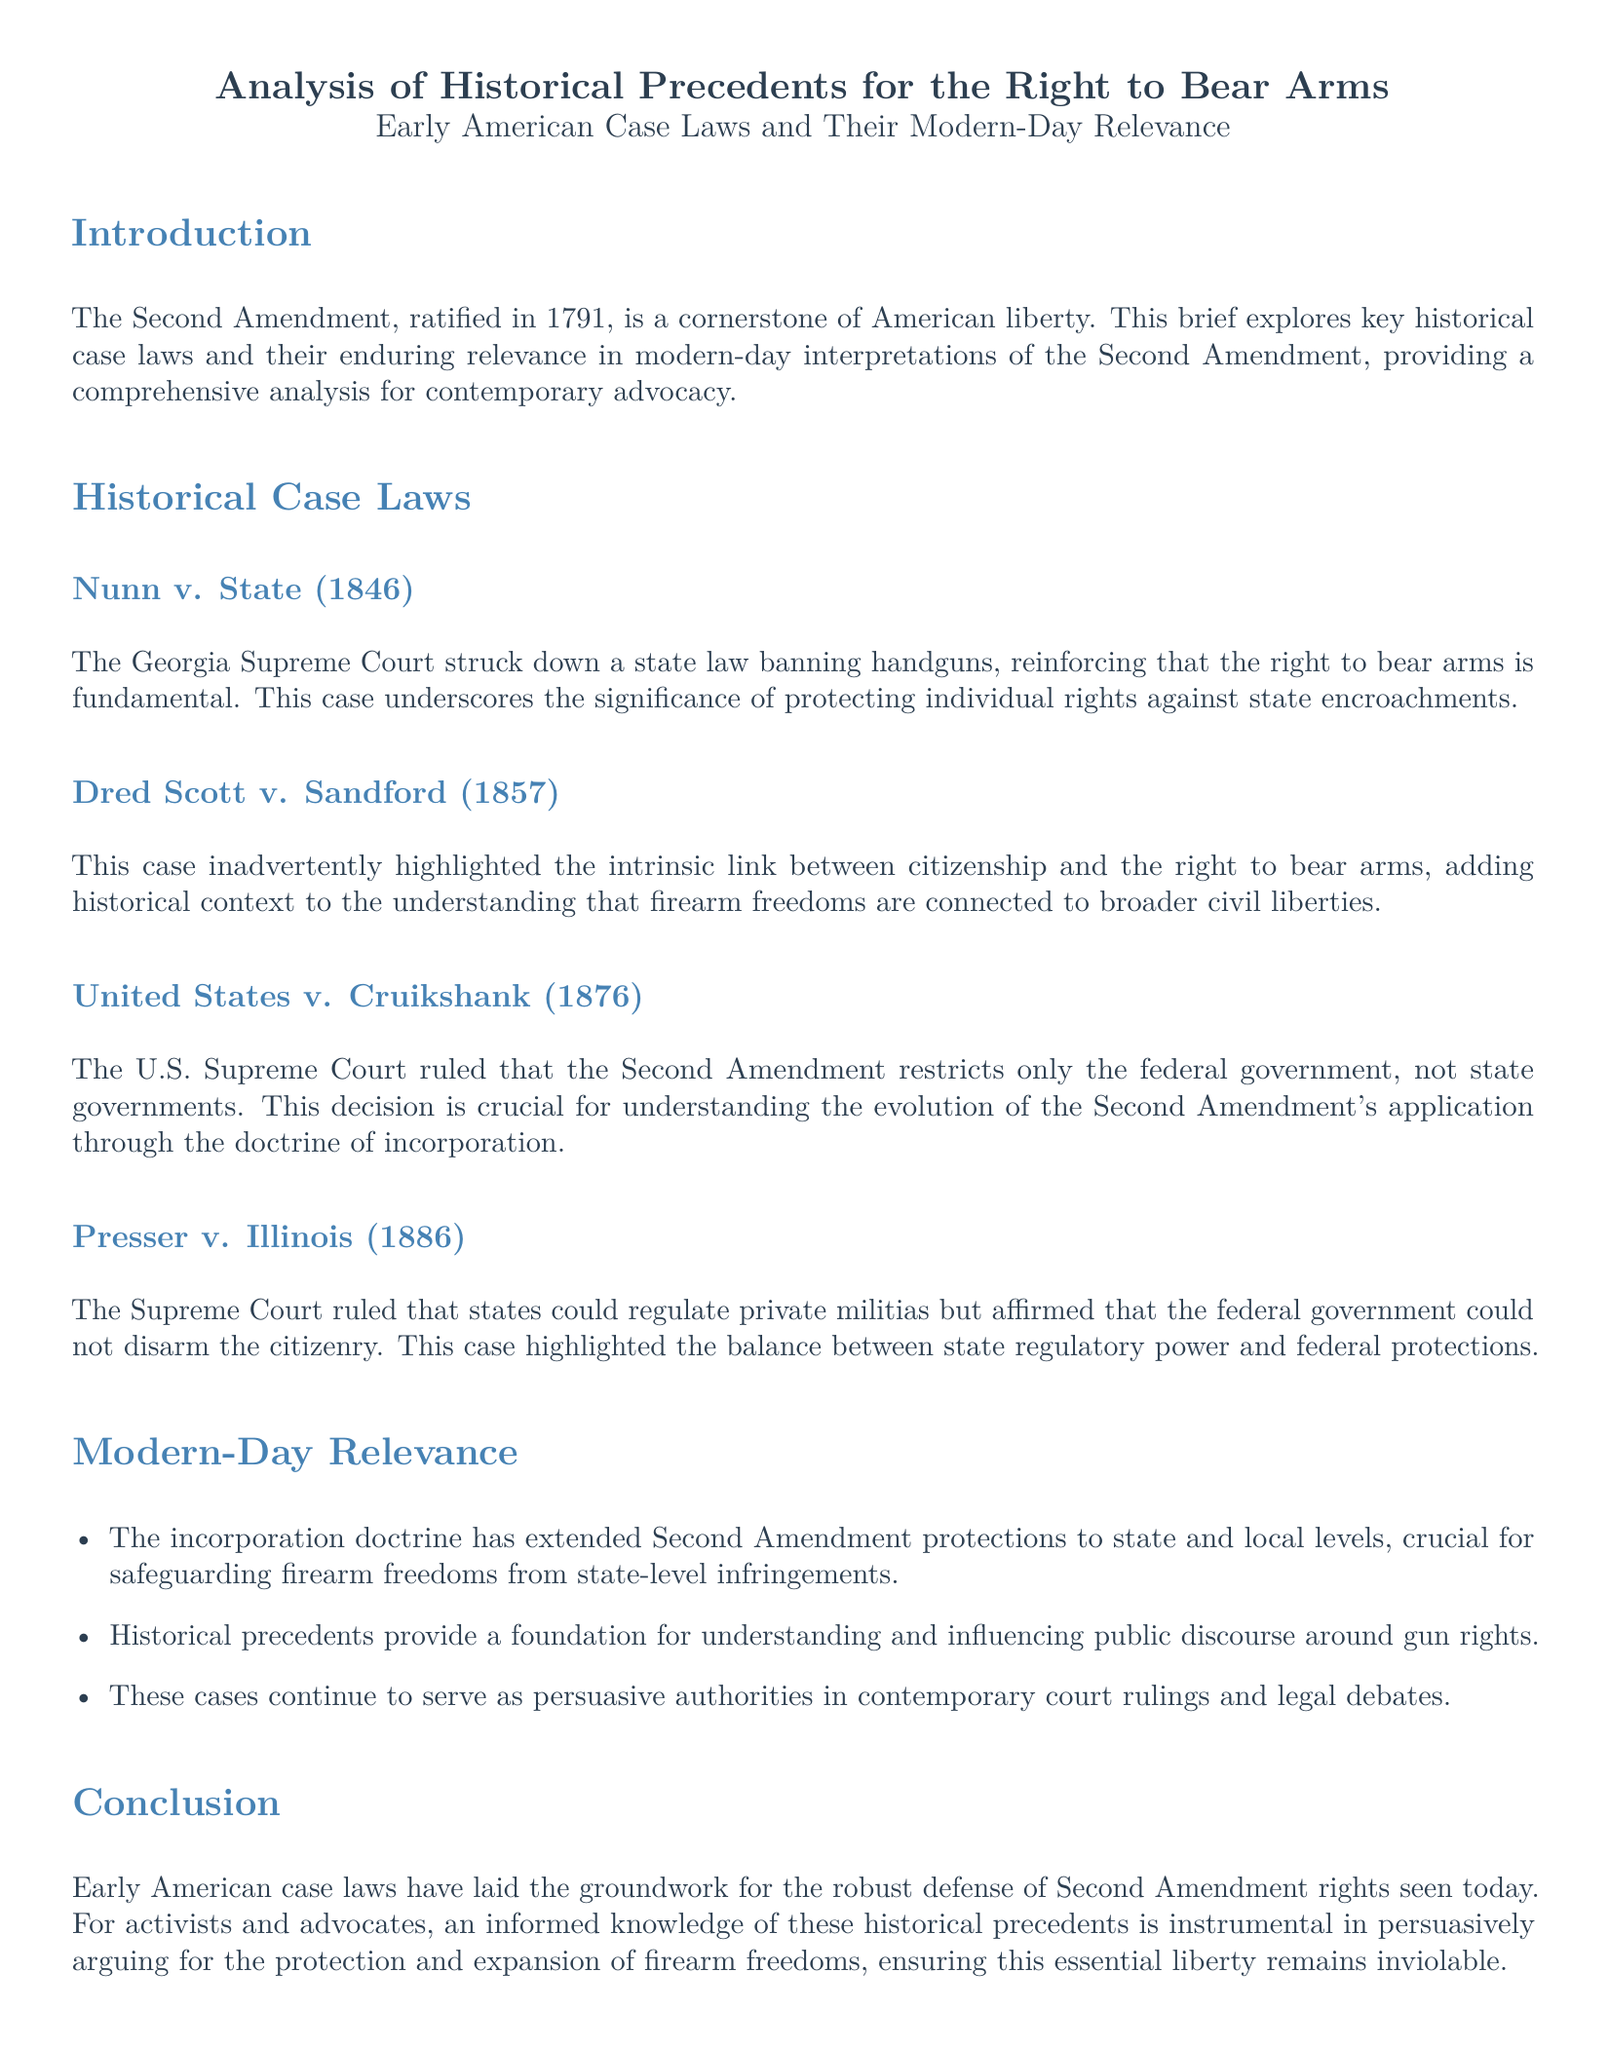What is the title of the document? The title of the document is located at the beginning section of the brief, which summarizes the content.
Answer: Analysis of Historical Precedents for the Right to Bear Arms What year was the Second Amendment ratified? The ratification year is stated in the introduction as part of the historical context for the right to bear arms.
Answer: 1791 Which case involved a ruling against a state law banning handguns? This case is noted under the Historical Case Laws section, specifically highlighting its impact on individual rights.
Answer: Nunn v. State What did the U.S. Supreme Court rule in United States v. Cruikshank? This ruling clarifies the extent of the Second Amendment's restrictions and is essential for understanding its application beyond federal governance.
Answer: The Second Amendment restricts only the federal government Which case emphasized the balance between state regulatory power and federal protections? This case is referenced in the discussion on militia regulation and citizen disarmament, illustrating this balance.
Answer: Presser v. Illinois What is one modern-day relevance of historical precedents mentioned in the document? The document outlines aspects that demonstrate how historical cases influence current legal discussions.
Answer: Incorporation doctrine How many historical case laws are discussed in the document? The number of cases mentioned can be determined by counting the entries within the Historical Case Laws section.
Answer: Four What does the brief say about the connection between firearm freedoms and civil liberties? This context is derived from historical case discussions, underscoring broader implications for rights.
Answer: Dred Scott v. Sandford 